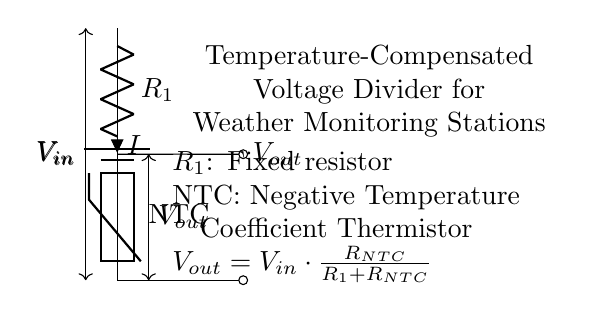What is the input voltage in the circuit? The input voltage is denoted as \( V_{in} \), which is the voltage supplied to the circuit. It's represented by a battery symbol at the top of the circuit diagram.
Answer: \( V_{in} \) What type of resistor is used in this circuit? The circuit contains a fixed resistor, represented as \( R_1 \), and a thermistor, which is indicated as a Negative Temperature Coefficient (NTC) thermistor. These identifiers are present next to their respective symbols in the diagram.
Answer: Fixed resistor and NTC What does \( V_{out} \) represent in the circuit? \( V_{out} \) represents the output voltage of the voltage divider, which can be measured across the thermistor. It's marked in the diagram at the point where the output is taken from the junction of \( R_1 \) and the NTC thermistor.
Answer: Output voltage How does temperature affect the output voltage? The output voltage is influenced by the NTC thermistor, which decreases its resistance with increasing temperature, leading to changes in \( V_{out} \). This relationship can be deduced from understanding the role of a thermistor in the voltage divider configuration.
Answer: Inverse relationship What is the formula for \( V_{out} \) in this voltage divider? The formula is given in the circuit diagram as \( V_{out} = V_{in} \cdot \frac{R_{NTC}}{R_1 + R_{NTC}} \). This equation shows how the output voltage is calculated based on the resistances in the circuit and the input voltage.
Answer: \( V_{out} = V_{in} \cdot \frac{R_{NTC}}{R_1 + R_{NTC}} \) What happens to \( V_{out} \) if the temperature drops? If the temperature drops, the resistance of the NTC thermistor increases, which, according to the voltage divider formula, would result in a higher \( V_{out} \). This change can be inferred from the behavior of NTC thermistors and the relationship defined by the voltage divider equation.
Answer: \( V_{out} \) increases 